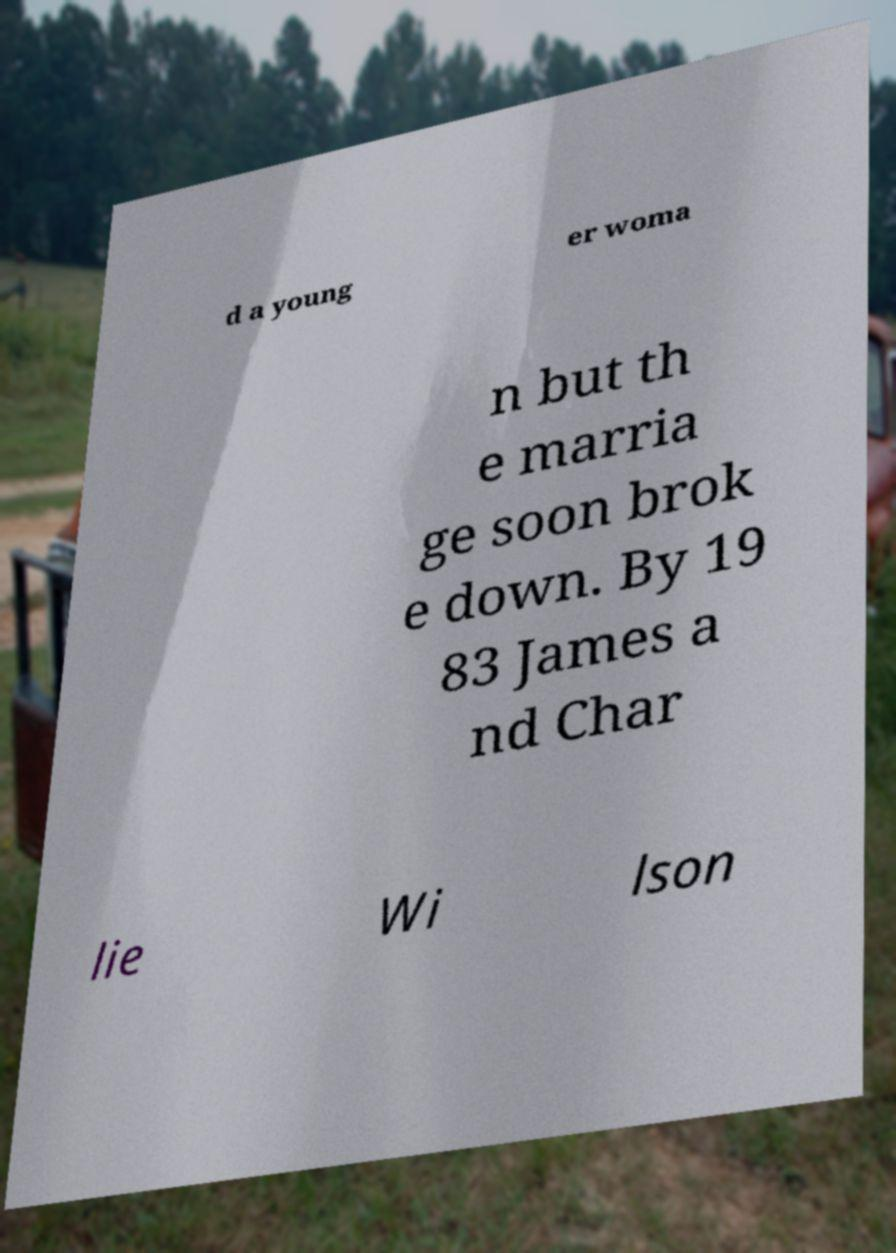Please identify and transcribe the text found in this image. d a young er woma n but th e marria ge soon brok e down. By 19 83 James a nd Char lie Wi lson 